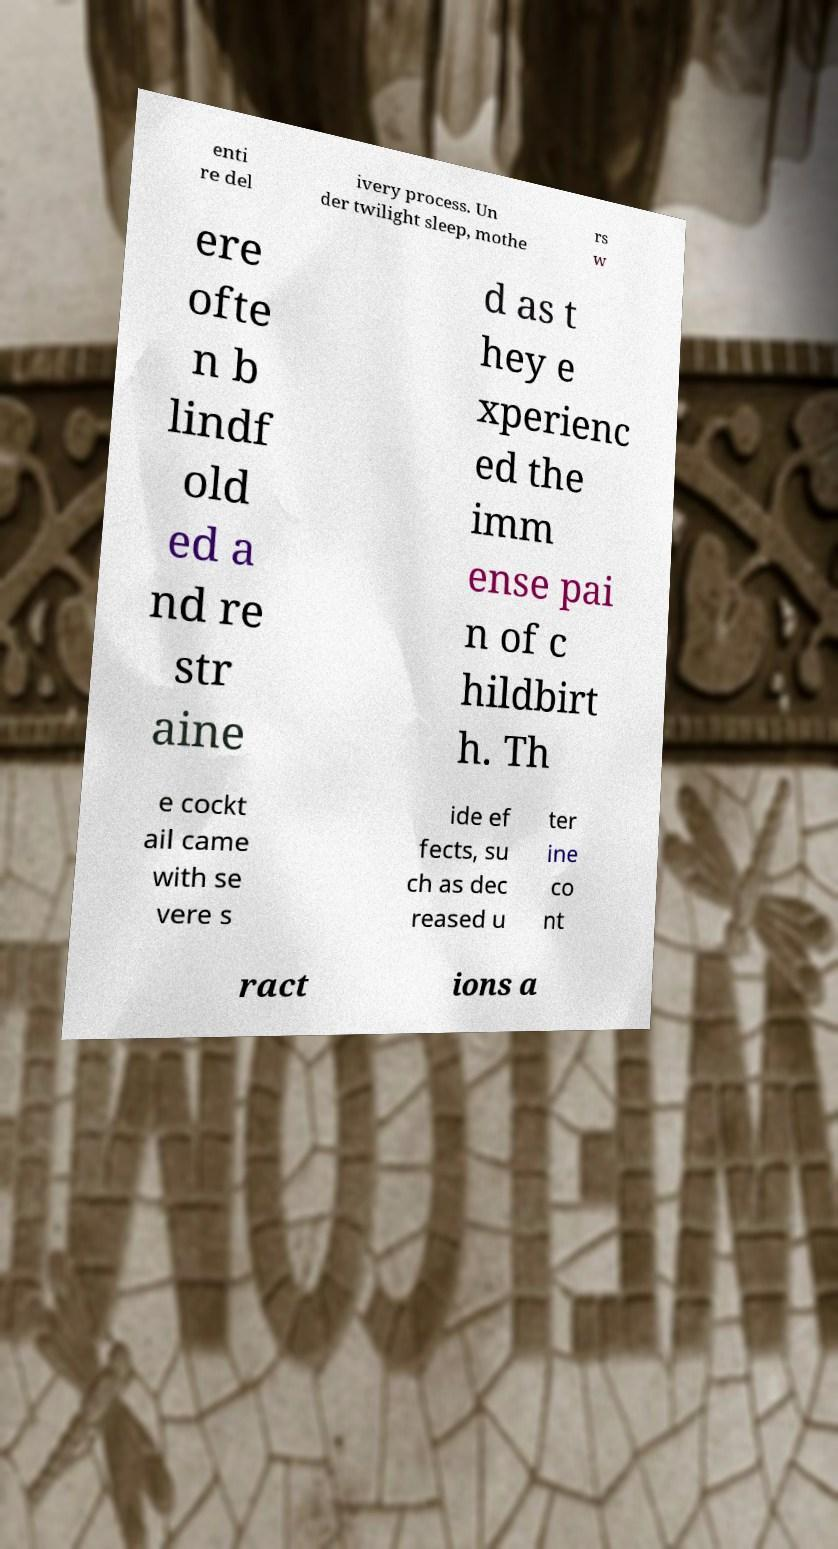Please identify and transcribe the text found in this image. enti re del ivery process. Un der twilight sleep, mothe rs w ere ofte n b lindf old ed a nd re str aine d as t hey e xperienc ed the imm ense pai n of c hildbirt h. Th e cockt ail came with se vere s ide ef fects, su ch as dec reased u ter ine co nt ract ions a 